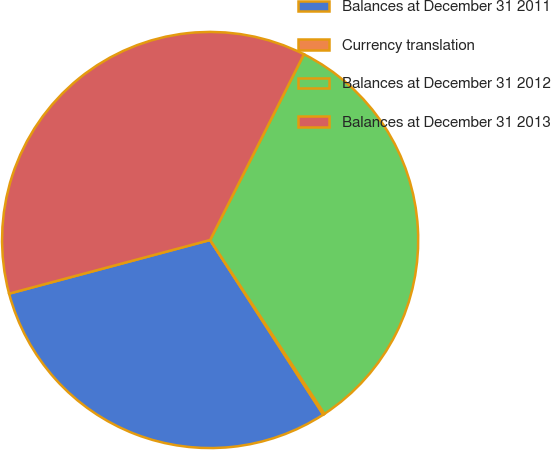Convert chart to OTSL. <chart><loc_0><loc_0><loc_500><loc_500><pie_chart><fcel>Balances at December 31 2011<fcel>Currency translation<fcel>Balances at December 31 2012<fcel>Balances at December 31 2013<nl><fcel>30.0%<fcel>0.11%<fcel>33.3%<fcel>36.6%<nl></chart> 